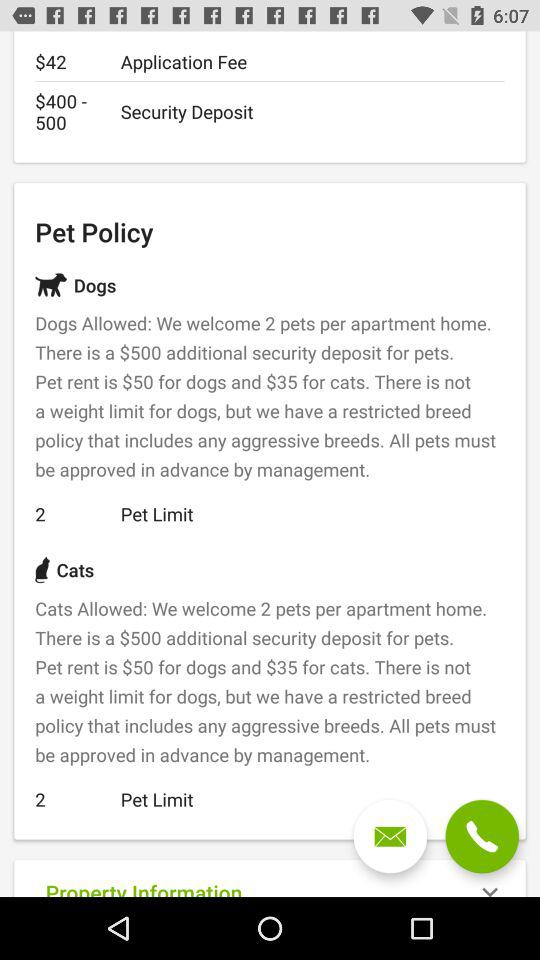What is the pet rent for dogs? The pet rent for dogs is $50. 